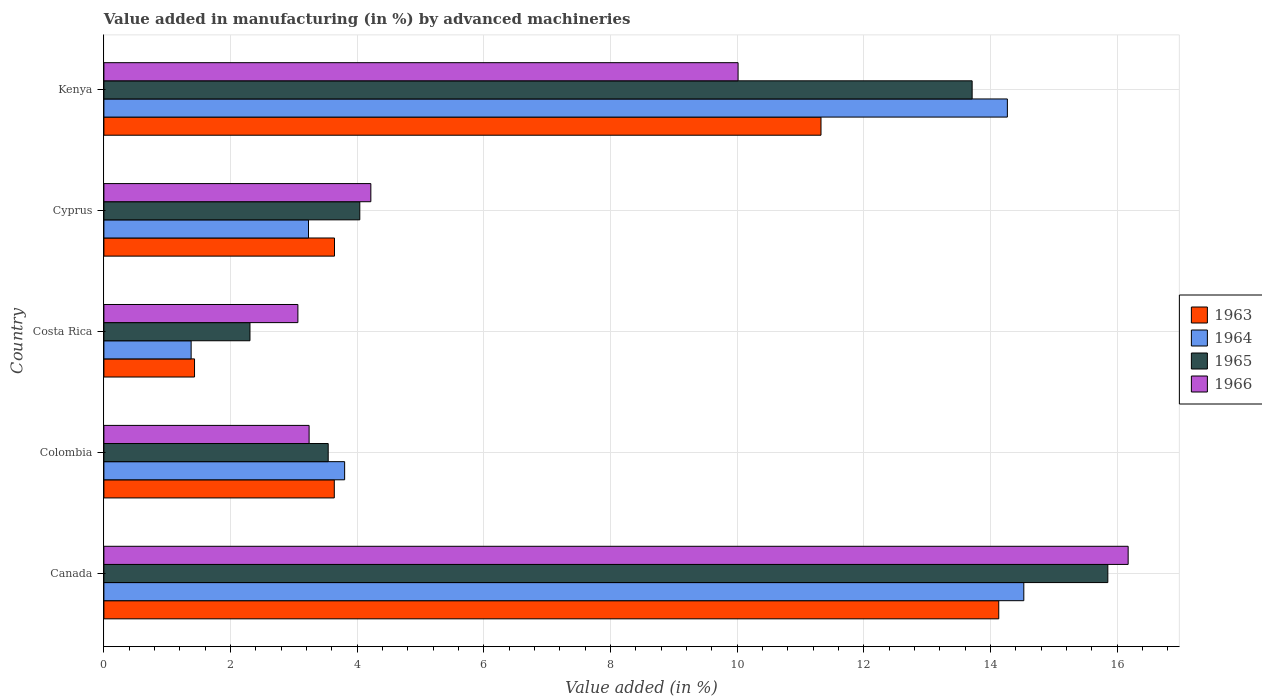How many different coloured bars are there?
Offer a very short reply. 4. Are the number of bars per tick equal to the number of legend labels?
Keep it short and to the point. Yes. How many bars are there on the 2nd tick from the bottom?
Offer a terse response. 4. What is the label of the 1st group of bars from the top?
Your response must be concise. Kenya. What is the percentage of value added in manufacturing by advanced machineries in 1965 in Kenya?
Give a very brief answer. 13.71. Across all countries, what is the maximum percentage of value added in manufacturing by advanced machineries in 1964?
Keep it short and to the point. 14.53. Across all countries, what is the minimum percentage of value added in manufacturing by advanced machineries in 1966?
Make the answer very short. 3.06. In which country was the percentage of value added in manufacturing by advanced machineries in 1966 maximum?
Ensure brevity in your answer.  Canada. What is the total percentage of value added in manufacturing by advanced machineries in 1964 in the graph?
Offer a terse response. 37.2. What is the difference between the percentage of value added in manufacturing by advanced machineries in 1963 in Colombia and that in Costa Rica?
Keep it short and to the point. 2.21. What is the difference between the percentage of value added in manufacturing by advanced machineries in 1966 in Cyprus and the percentage of value added in manufacturing by advanced machineries in 1963 in Costa Rica?
Keep it short and to the point. 2.78. What is the average percentage of value added in manufacturing by advanced machineries in 1965 per country?
Ensure brevity in your answer.  7.89. What is the difference between the percentage of value added in manufacturing by advanced machineries in 1966 and percentage of value added in manufacturing by advanced machineries in 1964 in Kenya?
Your answer should be very brief. -4.25. In how many countries, is the percentage of value added in manufacturing by advanced machineries in 1966 greater than 2.8 %?
Keep it short and to the point. 5. What is the ratio of the percentage of value added in manufacturing by advanced machineries in 1965 in Costa Rica to that in Cyprus?
Your answer should be compact. 0.57. What is the difference between the highest and the second highest percentage of value added in manufacturing by advanced machineries in 1963?
Offer a terse response. 2.81. What is the difference between the highest and the lowest percentage of value added in manufacturing by advanced machineries in 1964?
Make the answer very short. 13.15. In how many countries, is the percentage of value added in manufacturing by advanced machineries in 1966 greater than the average percentage of value added in manufacturing by advanced machineries in 1966 taken over all countries?
Ensure brevity in your answer.  2. Is it the case that in every country, the sum of the percentage of value added in manufacturing by advanced machineries in 1964 and percentage of value added in manufacturing by advanced machineries in 1963 is greater than the sum of percentage of value added in manufacturing by advanced machineries in 1966 and percentage of value added in manufacturing by advanced machineries in 1965?
Your answer should be very brief. No. What does the 3rd bar from the top in Kenya represents?
Your answer should be very brief. 1964. What does the 2nd bar from the bottom in Costa Rica represents?
Provide a succinct answer. 1964. Is it the case that in every country, the sum of the percentage of value added in manufacturing by advanced machineries in 1964 and percentage of value added in manufacturing by advanced machineries in 1963 is greater than the percentage of value added in manufacturing by advanced machineries in 1966?
Your answer should be compact. No. How many bars are there?
Offer a very short reply. 20. How many countries are there in the graph?
Offer a terse response. 5. Are the values on the major ticks of X-axis written in scientific E-notation?
Offer a very short reply. No. Does the graph contain any zero values?
Keep it short and to the point. No. How many legend labels are there?
Give a very brief answer. 4. How are the legend labels stacked?
Keep it short and to the point. Vertical. What is the title of the graph?
Make the answer very short. Value added in manufacturing (in %) by advanced machineries. What is the label or title of the X-axis?
Offer a very short reply. Value added (in %). What is the Value added (in %) in 1963 in Canada?
Offer a very short reply. 14.13. What is the Value added (in %) of 1964 in Canada?
Provide a succinct answer. 14.53. What is the Value added (in %) of 1965 in Canada?
Ensure brevity in your answer.  15.85. What is the Value added (in %) in 1966 in Canada?
Your response must be concise. 16.17. What is the Value added (in %) in 1963 in Colombia?
Ensure brevity in your answer.  3.64. What is the Value added (in %) of 1964 in Colombia?
Keep it short and to the point. 3.8. What is the Value added (in %) of 1965 in Colombia?
Provide a succinct answer. 3.54. What is the Value added (in %) of 1966 in Colombia?
Your answer should be very brief. 3.24. What is the Value added (in %) in 1963 in Costa Rica?
Offer a terse response. 1.43. What is the Value added (in %) of 1964 in Costa Rica?
Your answer should be very brief. 1.38. What is the Value added (in %) of 1965 in Costa Rica?
Provide a short and direct response. 2.31. What is the Value added (in %) in 1966 in Costa Rica?
Keep it short and to the point. 3.06. What is the Value added (in %) in 1963 in Cyprus?
Give a very brief answer. 3.64. What is the Value added (in %) in 1964 in Cyprus?
Provide a succinct answer. 3.23. What is the Value added (in %) in 1965 in Cyprus?
Provide a succinct answer. 4.04. What is the Value added (in %) in 1966 in Cyprus?
Your answer should be compact. 4.22. What is the Value added (in %) in 1963 in Kenya?
Ensure brevity in your answer.  11.32. What is the Value added (in %) of 1964 in Kenya?
Make the answer very short. 14.27. What is the Value added (in %) in 1965 in Kenya?
Your answer should be very brief. 13.71. What is the Value added (in %) in 1966 in Kenya?
Offer a very short reply. 10.01. Across all countries, what is the maximum Value added (in %) of 1963?
Keep it short and to the point. 14.13. Across all countries, what is the maximum Value added (in %) of 1964?
Give a very brief answer. 14.53. Across all countries, what is the maximum Value added (in %) of 1965?
Your answer should be very brief. 15.85. Across all countries, what is the maximum Value added (in %) in 1966?
Ensure brevity in your answer.  16.17. Across all countries, what is the minimum Value added (in %) of 1963?
Your answer should be very brief. 1.43. Across all countries, what is the minimum Value added (in %) in 1964?
Provide a short and direct response. 1.38. Across all countries, what is the minimum Value added (in %) of 1965?
Provide a succinct answer. 2.31. Across all countries, what is the minimum Value added (in %) in 1966?
Make the answer very short. 3.06. What is the total Value added (in %) of 1963 in the graph?
Offer a terse response. 34.16. What is the total Value added (in %) in 1964 in the graph?
Provide a succinct answer. 37.2. What is the total Value added (in %) in 1965 in the graph?
Your answer should be very brief. 39.45. What is the total Value added (in %) in 1966 in the graph?
Your response must be concise. 36.71. What is the difference between the Value added (in %) in 1963 in Canada and that in Colombia?
Offer a terse response. 10.49. What is the difference between the Value added (in %) in 1964 in Canada and that in Colombia?
Give a very brief answer. 10.72. What is the difference between the Value added (in %) of 1965 in Canada and that in Colombia?
Make the answer very short. 12.31. What is the difference between the Value added (in %) in 1966 in Canada and that in Colombia?
Your response must be concise. 12.93. What is the difference between the Value added (in %) in 1963 in Canada and that in Costa Rica?
Provide a short and direct response. 12.7. What is the difference between the Value added (in %) in 1964 in Canada and that in Costa Rica?
Offer a terse response. 13.15. What is the difference between the Value added (in %) in 1965 in Canada and that in Costa Rica?
Your answer should be compact. 13.55. What is the difference between the Value added (in %) of 1966 in Canada and that in Costa Rica?
Ensure brevity in your answer.  13.11. What is the difference between the Value added (in %) in 1963 in Canada and that in Cyprus?
Provide a succinct answer. 10.49. What is the difference between the Value added (in %) of 1964 in Canada and that in Cyprus?
Provide a short and direct response. 11.3. What is the difference between the Value added (in %) of 1965 in Canada and that in Cyprus?
Make the answer very short. 11.81. What is the difference between the Value added (in %) in 1966 in Canada and that in Cyprus?
Give a very brief answer. 11.96. What is the difference between the Value added (in %) of 1963 in Canada and that in Kenya?
Ensure brevity in your answer.  2.81. What is the difference between the Value added (in %) in 1964 in Canada and that in Kenya?
Provide a short and direct response. 0.26. What is the difference between the Value added (in %) in 1965 in Canada and that in Kenya?
Your answer should be compact. 2.14. What is the difference between the Value added (in %) of 1966 in Canada and that in Kenya?
Offer a very short reply. 6.16. What is the difference between the Value added (in %) of 1963 in Colombia and that in Costa Rica?
Make the answer very short. 2.21. What is the difference between the Value added (in %) in 1964 in Colombia and that in Costa Rica?
Ensure brevity in your answer.  2.42. What is the difference between the Value added (in %) of 1965 in Colombia and that in Costa Rica?
Keep it short and to the point. 1.24. What is the difference between the Value added (in %) in 1966 in Colombia and that in Costa Rica?
Offer a very short reply. 0.18. What is the difference between the Value added (in %) of 1963 in Colombia and that in Cyprus?
Your response must be concise. -0. What is the difference between the Value added (in %) of 1964 in Colombia and that in Cyprus?
Offer a terse response. 0.57. What is the difference between the Value added (in %) in 1965 in Colombia and that in Cyprus?
Your answer should be very brief. -0.5. What is the difference between the Value added (in %) of 1966 in Colombia and that in Cyprus?
Make the answer very short. -0.97. What is the difference between the Value added (in %) in 1963 in Colombia and that in Kenya?
Offer a terse response. -7.69. What is the difference between the Value added (in %) in 1964 in Colombia and that in Kenya?
Your answer should be very brief. -10.47. What is the difference between the Value added (in %) of 1965 in Colombia and that in Kenya?
Keep it short and to the point. -10.17. What is the difference between the Value added (in %) of 1966 in Colombia and that in Kenya?
Give a very brief answer. -6.77. What is the difference between the Value added (in %) in 1963 in Costa Rica and that in Cyprus?
Your response must be concise. -2.21. What is the difference between the Value added (in %) in 1964 in Costa Rica and that in Cyprus?
Keep it short and to the point. -1.85. What is the difference between the Value added (in %) of 1965 in Costa Rica and that in Cyprus?
Offer a very short reply. -1.73. What is the difference between the Value added (in %) of 1966 in Costa Rica and that in Cyprus?
Provide a succinct answer. -1.15. What is the difference between the Value added (in %) in 1963 in Costa Rica and that in Kenya?
Ensure brevity in your answer.  -9.89. What is the difference between the Value added (in %) of 1964 in Costa Rica and that in Kenya?
Provide a short and direct response. -12.89. What is the difference between the Value added (in %) of 1965 in Costa Rica and that in Kenya?
Your answer should be compact. -11.4. What is the difference between the Value added (in %) in 1966 in Costa Rica and that in Kenya?
Make the answer very short. -6.95. What is the difference between the Value added (in %) in 1963 in Cyprus and that in Kenya?
Your response must be concise. -7.68. What is the difference between the Value added (in %) of 1964 in Cyprus and that in Kenya?
Provide a short and direct response. -11.04. What is the difference between the Value added (in %) of 1965 in Cyprus and that in Kenya?
Your answer should be very brief. -9.67. What is the difference between the Value added (in %) of 1966 in Cyprus and that in Kenya?
Make the answer very short. -5.8. What is the difference between the Value added (in %) of 1963 in Canada and the Value added (in %) of 1964 in Colombia?
Keep it short and to the point. 10.33. What is the difference between the Value added (in %) in 1963 in Canada and the Value added (in %) in 1965 in Colombia?
Your response must be concise. 10.59. What is the difference between the Value added (in %) in 1963 in Canada and the Value added (in %) in 1966 in Colombia?
Provide a succinct answer. 10.89. What is the difference between the Value added (in %) of 1964 in Canada and the Value added (in %) of 1965 in Colombia?
Offer a terse response. 10.98. What is the difference between the Value added (in %) in 1964 in Canada and the Value added (in %) in 1966 in Colombia?
Make the answer very short. 11.29. What is the difference between the Value added (in %) of 1965 in Canada and the Value added (in %) of 1966 in Colombia?
Provide a short and direct response. 12.61. What is the difference between the Value added (in %) in 1963 in Canada and the Value added (in %) in 1964 in Costa Rica?
Provide a succinct answer. 12.75. What is the difference between the Value added (in %) of 1963 in Canada and the Value added (in %) of 1965 in Costa Rica?
Provide a short and direct response. 11.82. What is the difference between the Value added (in %) of 1963 in Canada and the Value added (in %) of 1966 in Costa Rica?
Your answer should be very brief. 11.07. What is the difference between the Value added (in %) in 1964 in Canada and the Value added (in %) in 1965 in Costa Rica?
Give a very brief answer. 12.22. What is the difference between the Value added (in %) in 1964 in Canada and the Value added (in %) in 1966 in Costa Rica?
Your answer should be compact. 11.46. What is the difference between the Value added (in %) of 1965 in Canada and the Value added (in %) of 1966 in Costa Rica?
Keep it short and to the point. 12.79. What is the difference between the Value added (in %) of 1963 in Canada and the Value added (in %) of 1964 in Cyprus?
Provide a short and direct response. 10.9. What is the difference between the Value added (in %) in 1963 in Canada and the Value added (in %) in 1965 in Cyprus?
Keep it short and to the point. 10.09. What is the difference between the Value added (in %) of 1963 in Canada and the Value added (in %) of 1966 in Cyprus?
Your answer should be very brief. 9.92. What is the difference between the Value added (in %) of 1964 in Canada and the Value added (in %) of 1965 in Cyprus?
Make the answer very short. 10.49. What is the difference between the Value added (in %) in 1964 in Canada and the Value added (in %) in 1966 in Cyprus?
Provide a succinct answer. 10.31. What is the difference between the Value added (in %) in 1965 in Canada and the Value added (in %) in 1966 in Cyprus?
Offer a terse response. 11.64. What is the difference between the Value added (in %) of 1963 in Canada and the Value added (in %) of 1964 in Kenya?
Offer a very short reply. -0.14. What is the difference between the Value added (in %) of 1963 in Canada and the Value added (in %) of 1965 in Kenya?
Your answer should be compact. 0.42. What is the difference between the Value added (in %) in 1963 in Canada and the Value added (in %) in 1966 in Kenya?
Your answer should be compact. 4.12. What is the difference between the Value added (in %) in 1964 in Canada and the Value added (in %) in 1965 in Kenya?
Ensure brevity in your answer.  0.82. What is the difference between the Value added (in %) in 1964 in Canada and the Value added (in %) in 1966 in Kenya?
Provide a succinct answer. 4.51. What is the difference between the Value added (in %) of 1965 in Canada and the Value added (in %) of 1966 in Kenya?
Your answer should be compact. 5.84. What is the difference between the Value added (in %) of 1963 in Colombia and the Value added (in %) of 1964 in Costa Rica?
Ensure brevity in your answer.  2.26. What is the difference between the Value added (in %) of 1963 in Colombia and the Value added (in %) of 1965 in Costa Rica?
Provide a succinct answer. 1.33. What is the difference between the Value added (in %) in 1963 in Colombia and the Value added (in %) in 1966 in Costa Rica?
Offer a terse response. 0.57. What is the difference between the Value added (in %) in 1964 in Colombia and the Value added (in %) in 1965 in Costa Rica?
Give a very brief answer. 1.49. What is the difference between the Value added (in %) in 1964 in Colombia and the Value added (in %) in 1966 in Costa Rica?
Your answer should be very brief. 0.74. What is the difference between the Value added (in %) of 1965 in Colombia and the Value added (in %) of 1966 in Costa Rica?
Your answer should be very brief. 0.48. What is the difference between the Value added (in %) of 1963 in Colombia and the Value added (in %) of 1964 in Cyprus?
Keep it short and to the point. 0.41. What is the difference between the Value added (in %) in 1963 in Colombia and the Value added (in %) in 1965 in Cyprus?
Provide a short and direct response. -0.4. What is the difference between the Value added (in %) of 1963 in Colombia and the Value added (in %) of 1966 in Cyprus?
Make the answer very short. -0.58. What is the difference between the Value added (in %) in 1964 in Colombia and the Value added (in %) in 1965 in Cyprus?
Provide a short and direct response. -0.24. What is the difference between the Value added (in %) of 1964 in Colombia and the Value added (in %) of 1966 in Cyprus?
Your response must be concise. -0.41. What is the difference between the Value added (in %) of 1965 in Colombia and the Value added (in %) of 1966 in Cyprus?
Offer a very short reply. -0.67. What is the difference between the Value added (in %) in 1963 in Colombia and the Value added (in %) in 1964 in Kenya?
Your answer should be very brief. -10.63. What is the difference between the Value added (in %) in 1963 in Colombia and the Value added (in %) in 1965 in Kenya?
Ensure brevity in your answer.  -10.07. What is the difference between the Value added (in %) of 1963 in Colombia and the Value added (in %) of 1966 in Kenya?
Provide a short and direct response. -6.38. What is the difference between the Value added (in %) in 1964 in Colombia and the Value added (in %) in 1965 in Kenya?
Offer a terse response. -9.91. What is the difference between the Value added (in %) of 1964 in Colombia and the Value added (in %) of 1966 in Kenya?
Make the answer very short. -6.21. What is the difference between the Value added (in %) in 1965 in Colombia and the Value added (in %) in 1966 in Kenya?
Provide a succinct answer. -6.47. What is the difference between the Value added (in %) in 1963 in Costa Rica and the Value added (in %) in 1964 in Cyprus?
Offer a very short reply. -1.8. What is the difference between the Value added (in %) of 1963 in Costa Rica and the Value added (in %) of 1965 in Cyprus?
Provide a short and direct response. -2.61. What is the difference between the Value added (in %) in 1963 in Costa Rica and the Value added (in %) in 1966 in Cyprus?
Offer a terse response. -2.78. What is the difference between the Value added (in %) of 1964 in Costa Rica and the Value added (in %) of 1965 in Cyprus?
Offer a terse response. -2.66. What is the difference between the Value added (in %) in 1964 in Costa Rica and the Value added (in %) in 1966 in Cyprus?
Provide a succinct answer. -2.84. What is the difference between the Value added (in %) in 1965 in Costa Rica and the Value added (in %) in 1966 in Cyprus?
Offer a terse response. -1.91. What is the difference between the Value added (in %) in 1963 in Costa Rica and the Value added (in %) in 1964 in Kenya?
Your answer should be compact. -12.84. What is the difference between the Value added (in %) of 1963 in Costa Rica and the Value added (in %) of 1965 in Kenya?
Provide a short and direct response. -12.28. What is the difference between the Value added (in %) of 1963 in Costa Rica and the Value added (in %) of 1966 in Kenya?
Provide a succinct answer. -8.58. What is the difference between the Value added (in %) in 1964 in Costa Rica and the Value added (in %) in 1965 in Kenya?
Give a very brief answer. -12.33. What is the difference between the Value added (in %) in 1964 in Costa Rica and the Value added (in %) in 1966 in Kenya?
Your response must be concise. -8.64. What is the difference between the Value added (in %) in 1965 in Costa Rica and the Value added (in %) in 1966 in Kenya?
Your response must be concise. -7.71. What is the difference between the Value added (in %) in 1963 in Cyprus and the Value added (in %) in 1964 in Kenya?
Keep it short and to the point. -10.63. What is the difference between the Value added (in %) of 1963 in Cyprus and the Value added (in %) of 1965 in Kenya?
Your answer should be compact. -10.07. What is the difference between the Value added (in %) in 1963 in Cyprus and the Value added (in %) in 1966 in Kenya?
Your answer should be compact. -6.37. What is the difference between the Value added (in %) of 1964 in Cyprus and the Value added (in %) of 1965 in Kenya?
Make the answer very short. -10.48. What is the difference between the Value added (in %) of 1964 in Cyprus and the Value added (in %) of 1966 in Kenya?
Provide a short and direct response. -6.78. What is the difference between the Value added (in %) in 1965 in Cyprus and the Value added (in %) in 1966 in Kenya?
Provide a short and direct response. -5.97. What is the average Value added (in %) in 1963 per country?
Provide a short and direct response. 6.83. What is the average Value added (in %) in 1964 per country?
Your response must be concise. 7.44. What is the average Value added (in %) of 1965 per country?
Your answer should be very brief. 7.89. What is the average Value added (in %) of 1966 per country?
Ensure brevity in your answer.  7.34. What is the difference between the Value added (in %) in 1963 and Value added (in %) in 1964 in Canada?
Ensure brevity in your answer.  -0.4. What is the difference between the Value added (in %) of 1963 and Value added (in %) of 1965 in Canada?
Provide a short and direct response. -1.72. What is the difference between the Value added (in %) of 1963 and Value added (in %) of 1966 in Canada?
Provide a succinct answer. -2.04. What is the difference between the Value added (in %) in 1964 and Value added (in %) in 1965 in Canada?
Offer a terse response. -1.33. What is the difference between the Value added (in %) in 1964 and Value added (in %) in 1966 in Canada?
Provide a succinct answer. -1.65. What is the difference between the Value added (in %) of 1965 and Value added (in %) of 1966 in Canada?
Provide a succinct answer. -0.32. What is the difference between the Value added (in %) in 1963 and Value added (in %) in 1964 in Colombia?
Make the answer very short. -0.16. What is the difference between the Value added (in %) in 1963 and Value added (in %) in 1965 in Colombia?
Offer a very short reply. 0.1. What is the difference between the Value added (in %) of 1963 and Value added (in %) of 1966 in Colombia?
Provide a succinct answer. 0.4. What is the difference between the Value added (in %) of 1964 and Value added (in %) of 1965 in Colombia?
Give a very brief answer. 0.26. What is the difference between the Value added (in %) in 1964 and Value added (in %) in 1966 in Colombia?
Give a very brief answer. 0.56. What is the difference between the Value added (in %) of 1965 and Value added (in %) of 1966 in Colombia?
Offer a terse response. 0.3. What is the difference between the Value added (in %) in 1963 and Value added (in %) in 1964 in Costa Rica?
Ensure brevity in your answer.  0.05. What is the difference between the Value added (in %) in 1963 and Value added (in %) in 1965 in Costa Rica?
Offer a very short reply. -0.88. What is the difference between the Value added (in %) of 1963 and Value added (in %) of 1966 in Costa Rica?
Your answer should be compact. -1.63. What is the difference between the Value added (in %) in 1964 and Value added (in %) in 1965 in Costa Rica?
Provide a short and direct response. -0.93. What is the difference between the Value added (in %) in 1964 and Value added (in %) in 1966 in Costa Rica?
Your answer should be very brief. -1.69. What is the difference between the Value added (in %) of 1965 and Value added (in %) of 1966 in Costa Rica?
Make the answer very short. -0.76. What is the difference between the Value added (in %) in 1963 and Value added (in %) in 1964 in Cyprus?
Provide a short and direct response. 0.41. What is the difference between the Value added (in %) of 1963 and Value added (in %) of 1965 in Cyprus?
Offer a terse response. -0.4. What is the difference between the Value added (in %) in 1963 and Value added (in %) in 1966 in Cyprus?
Provide a short and direct response. -0.57. What is the difference between the Value added (in %) in 1964 and Value added (in %) in 1965 in Cyprus?
Offer a very short reply. -0.81. What is the difference between the Value added (in %) in 1964 and Value added (in %) in 1966 in Cyprus?
Keep it short and to the point. -0.98. What is the difference between the Value added (in %) of 1965 and Value added (in %) of 1966 in Cyprus?
Provide a short and direct response. -0.17. What is the difference between the Value added (in %) of 1963 and Value added (in %) of 1964 in Kenya?
Make the answer very short. -2.94. What is the difference between the Value added (in %) of 1963 and Value added (in %) of 1965 in Kenya?
Offer a terse response. -2.39. What is the difference between the Value added (in %) of 1963 and Value added (in %) of 1966 in Kenya?
Make the answer very short. 1.31. What is the difference between the Value added (in %) in 1964 and Value added (in %) in 1965 in Kenya?
Make the answer very short. 0.56. What is the difference between the Value added (in %) of 1964 and Value added (in %) of 1966 in Kenya?
Your response must be concise. 4.25. What is the difference between the Value added (in %) in 1965 and Value added (in %) in 1966 in Kenya?
Ensure brevity in your answer.  3.7. What is the ratio of the Value added (in %) of 1963 in Canada to that in Colombia?
Keep it short and to the point. 3.88. What is the ratio of the Value added (in %) in 1964 in Canada to that in Colombia?
Your response must be concise. 3.82. What is the ratio of the Value added (in %) in 1965 in Canada to that in Colombia?
Provide a short and direct response. 4.48. What is the ratio of the Value added (in %) in 1966 in Canada to that in Colombia?
Your response must be concise. 4.99. What is the ratio of the Value added (in %) in 1963 in Canada to that in Costa Rica?
Offer a terse response. 9.87. What is the ratio of the Value added (in %) of 1964 in Canada to that in Costa Rica?
Provide a short and direct response. 10.54. What is the ratio of the Value added (in %) of 1965 in Canada to that in Costa Rica?
Your answer should be compact. 6.87. What is the ratio of the Value added (in %) of 1966 in Canada to that in Costa Rica?
Provide a succinct answer. 5.28. What is the ratio of the Value added (in %) of 1963 in Canada to that in Cyprus?
Your answer should be very brief. 3.88. What is the ratio of the Value added (in %) in 1964 in Canada to that in Cyprus?
Your answer should be compact. 4.5. What is the ratio of the Value added (in %) in 1965 in Canada to that in Cyprus?
Provide a short and direct response. 3.92. What is the ratio of the Value added (in %) of 1966 in Canada to that in Cyprus?
Offer a terse response. 3.84. What is the ratio of the Value added (in %) in 1963 in Canada to that in Kenya?
Keep it short and to the point. 1.25. What is the ratio of the Value added (in %) in 1964 in Canada to that in Kenya?
Your answer should be compact. 1.02. What is the ratio of the Value added (in %) in 1965 in Canada to that in Kenya?
Ensure brevity in your answer.  1.16. What is the ratio of the Value added (in %) in 1966 in Canada to that in Kenya?
Ensure brevity in your answer.  1.62. What is the ratio of the Value added (in %) in 1963 in Colombia to that in Costa Rica?
Keep it short and to the point. 2.54. What is the ratio of the Value added (in %) of 1964 in Colombia to that in Costa Rica?
Offer a terse response. 2.76. What is the ratio of the Value added (in %) in 1965 in Colombia to that in Costa Rica?
Make the answer very short. 1.54. What is the ratio of the Value added (in %) of 1966 in Colombia to that in Costa Rica?
Keep it short and to the point. 1.06. What is the ratio of the Value added (in %) of 1964 in Colombia to that in Cyprus?
Offer a very short reply. 1.18. What is the ratio of the Value added (in %) of 1965 in Colombia to that in Cyprus?
Offer a very short reply. 0.88. What is the ratio of the Value added (in %) in 1966 in Colombia to that in Cyprus?
Offer a very short reply. 0.77. What is the ratio of the Value added (in %) of 1963 in Colombia to that in Kenya?
Offer a terse response. 0.32. What is the ratio of the Value added (in %) of 1964 in Colombia to that in Kenya?
Give a very brief answer. 0.27. What is the ratio of the Value added (in %) in 1965 in Colombia to that in Kenya?
Make the answer very short. 0.26. What is the ratio of the Value added (in %) of 1966 in Colombia to that in Kenya?
Your response must be concise. 0.32. What is the ratio of the Value added (in %) of 1963 in Costa Rica to that in Cyprus?
Offer a very short reply. 0.39. What is the ratio of the Value added (in %) in 1964 in Costa Rica to that in Cyprus?
Make the answer very short. 0.43. What is the ratio of the Value added (in %) in 1965 in Costa Rica to that in Cyprus?
Your answer should be compact. 0.57. What is the ratio of the Value added (in %) of 1966 in Costa Rica to that in Cyprus?
Provide a succinct answer. 0.73. What is the ratio of the Value added (in %) in 1963 in Costa Rica to that in Kenya?
Keep it short and to the point. 0.13. What is the ratio of the Value added (in %) in 1964 in Costa Rica to that in Kenya?
Offer a terse response. 0.1. What is the ratio of the Value added (in %) in 1965 in Costa Rica to that in Kenya?
Your answer should be very brief. 0.17. What is the ratio of the Value added (in %) of 1966 in Costa Rica to that in Kenya?
Your response must be concise. 0.31. What is the ratio of the Value added (in %) in 1963 in Cyprus to that in Kenya?
Give a very brief answer. 0.32. What is the ratio of the Value added (in %) in 1964 in Cyprus to that in Kenya?
Keep it short and to the point. 0.23. What is the ratio of the Value added (in %) of 1965 in Cyprus to that in Kenya?
Your answer should be compact. 0.29. What is the ratio of the Value added (in %) in 1966 in Cyprus to that in Kenya?
Ensure brevity in your answer.  0.42. What is the difference between the highest and the second highest Value added (in %) of 1963?
Give a very brief answer. 2.81. What is the difference between the highest and the second highest Value added (in %) in 1964?
Your answer should be compact. 0.26. What is the difference between the highest and the second highest Value added (in %) in 1965?
Offer a terse response. 2.14. What is the difference between the highest and the second highest Value added (in %) of 1966?
Your response must be concise. 6.16. What is the difference between the highest and the lowest Value added (in %) in 1963?
Your response must be concise. 12.7. What is the difference between the highest and the lowest Value added (in %) of 1964?
Ensure brevity in your answer.  13.15. What is the difference between the highest and the lowest Value added (in %) in 1965?
Make the answer very short. 13.55. What is the difference between the highest and the lowest Value added (in %) in 1966?
Provide a short and direct response. 13.11. 